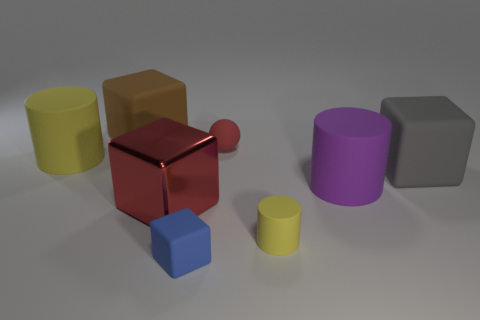Can you describe the smallest object in the image and what it is made of? Certainly! The smallest object in the image is a small yellow cylinder. It looks like it could be made of a matte plastic material due to its opaque surface and even coloring. 